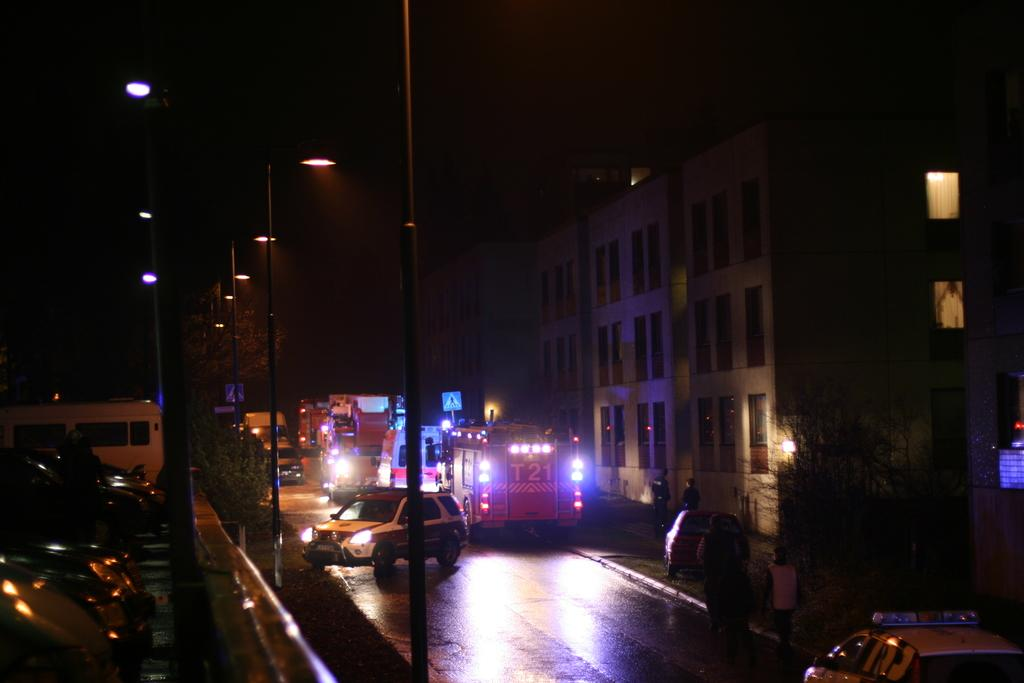What type of structures can be seen in the image? There are buildings in the image. What else is visible besides the buildings? There are vehicles, electric light poles, persons, windows, a road, and a sky visible in the image. Can you describe the road in the image? The road is at the bottom of the image. What is visible at the top of the image? There is a sky visible at the top of the image. How many oranges are being carried by the horse in the image? There is no horse or oranges present in the image. Is there a spy observing the scene in the image? There is no indication of a spy or any secretive activity in the image. 